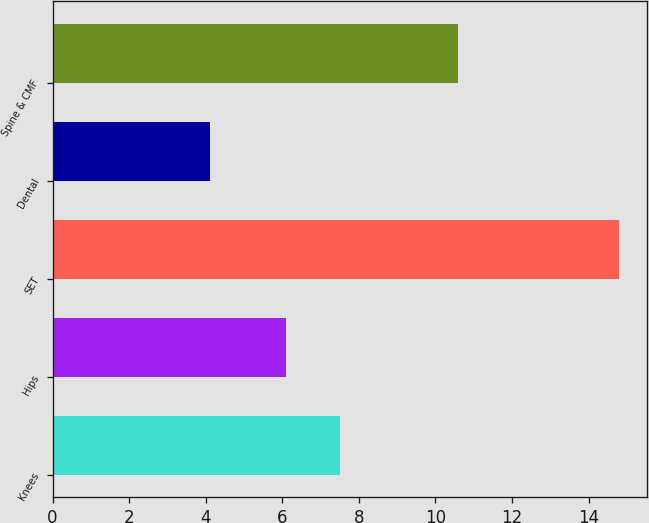<chart> <loc_0><loc_0><loc_500><loc_500><bar_chart><fcel>Knees<fcel>Hips<fcel>SET<fcel>Dental<fcel>Spine & CMF<nl><fcel>7.5<fcel>6.1<fcel>14.8<fcel>4.1<fcel>10.6<nl></chart> 